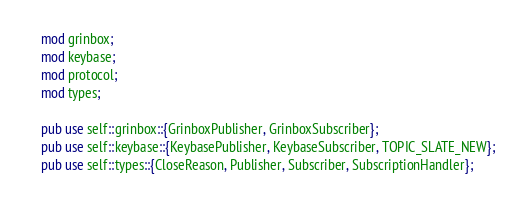Convert code to text. <code><loc_0><loc_0><loc_500><loc_500><_Rust_>mod grinbox;
mod keybase;
mod protocol;
mod types;

pub use self::grinbox::{GrinboxPublisher, GrinboxSubscriber};
pub use self::keybase::{KeybasePublisher, KeybaseSubscriber, TOPIC_SLATE_NEW};
pub use self::types::{CloseReason, Publisher, Subscriber, SubscriptionHandler};
</code> 